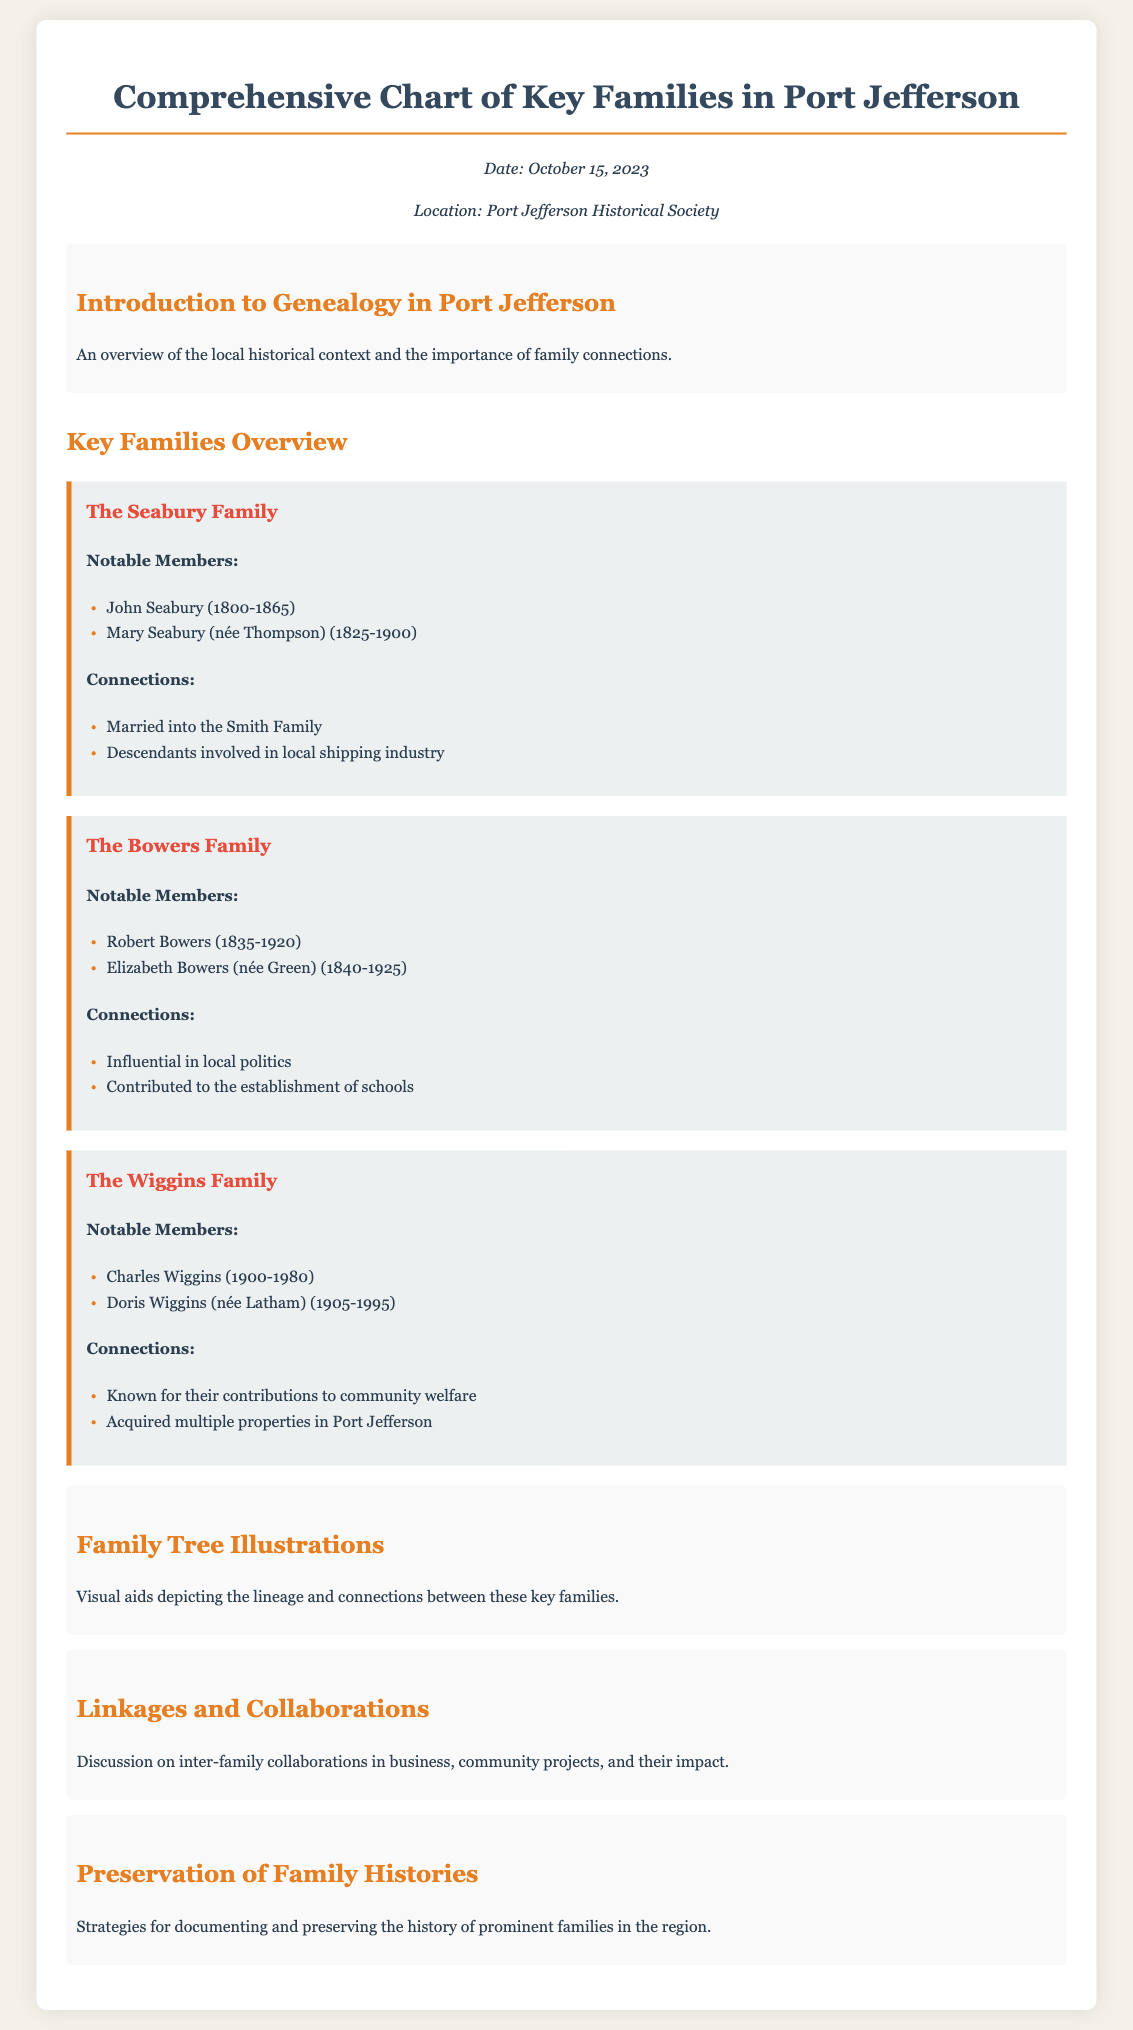What date is the document dated? The document specifies the date at the top in the date-location section as October 15, 2023.
Answer: October 15, 2023 Which family is known for contributions to community welfare? The document states that the Wiggins Family is known for their contributions to community welfare.
Answer: Wiggins Family Who are the notable members of the Bowers Family? The document lists Robert Bowers and Elizabeth Bowers as notable members of the Bowers Family.
Answer: Robert Bowers, Elizabeth Bowers What type of projects did the families collaborate on? The document mentions that the discussion includes inter-family collaborations in community projects.
Answer: Community projects Which family married into the Smith Family? The document indicates that the Seabury Family married into the Smith Family.
Answer: Seabury Family What is the primary focus of the section "Preservation of Family Histories"? The document describes strategies for documenting and preserving the history of families.
Answer: Documenting and preserving history Who is the historical context overview intended for? The introduction covers the local historical context and the importance of family connections for researchers and genealogists.
Answer: Researchers and genealogists What color is used for the family section headings? The document uses a red color (#e74c3c) for the family section headings.
Answer: Red What is the maximum width of the container in the document? The document states that the maximum width of the container is 1000 pixels.
Answer: 1000 pixels 